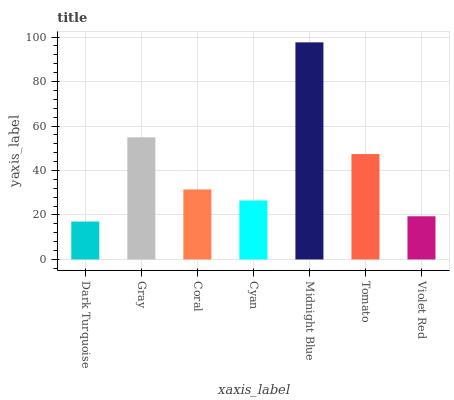Is Dark Turquoise the minimum?
Answer yes or no. Yes. Is Midnight Blue the maximum?
Answer yes or no. Yes. Is Gray the minimum?
Answer yes or no. No. Is Gray the maximum?
Answer yes or no. No. Is Gray greater than Dark Turquoise?
Answer yes or no. Yes. Is Dark Turquoise less than Gray?
Answer yes or no. Yes. Is Dark Turquoise greater than Gray?
Answer yes or no. No. Is Gray less than Dark Turquoise?
Answer yes or no. No. Is Coral the high median?
Answer yes or no. Yes. Is Coral the low median?
Answer yes or no. Yes. Is Gray the high median?
Answer yes or no. No. Is Tomato the low median?
Answer yes or no. No. 